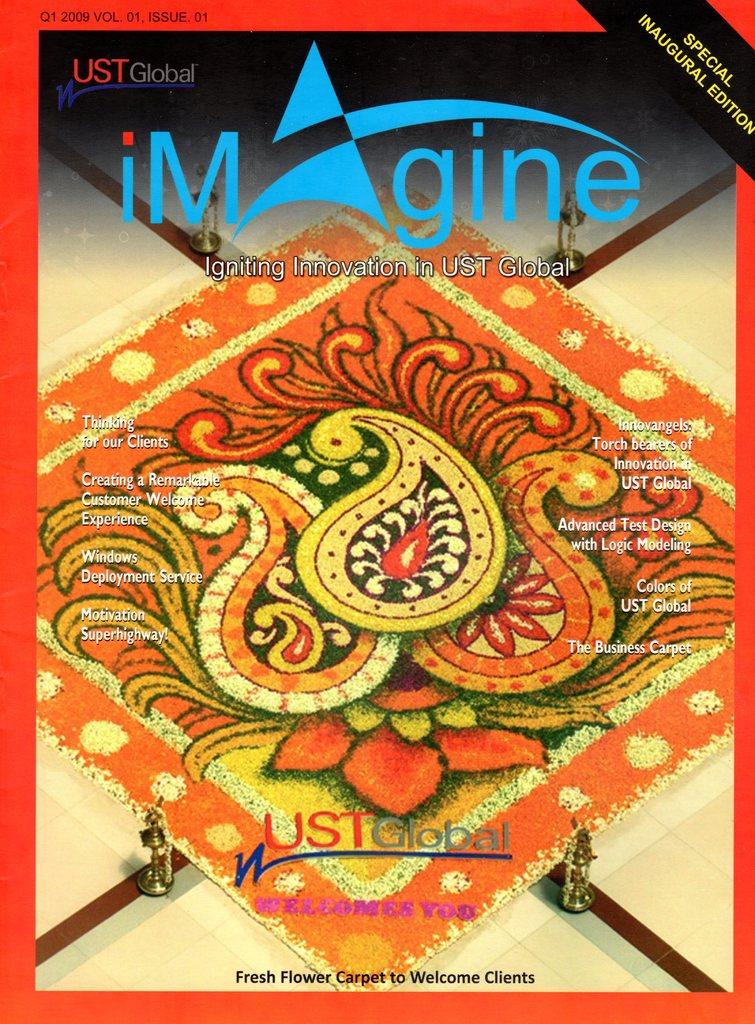What is written on the cover?
Your answer should be compact. Imagine. Which edition is this publication?
Provide a succinct answer. Special inaugural edition. 